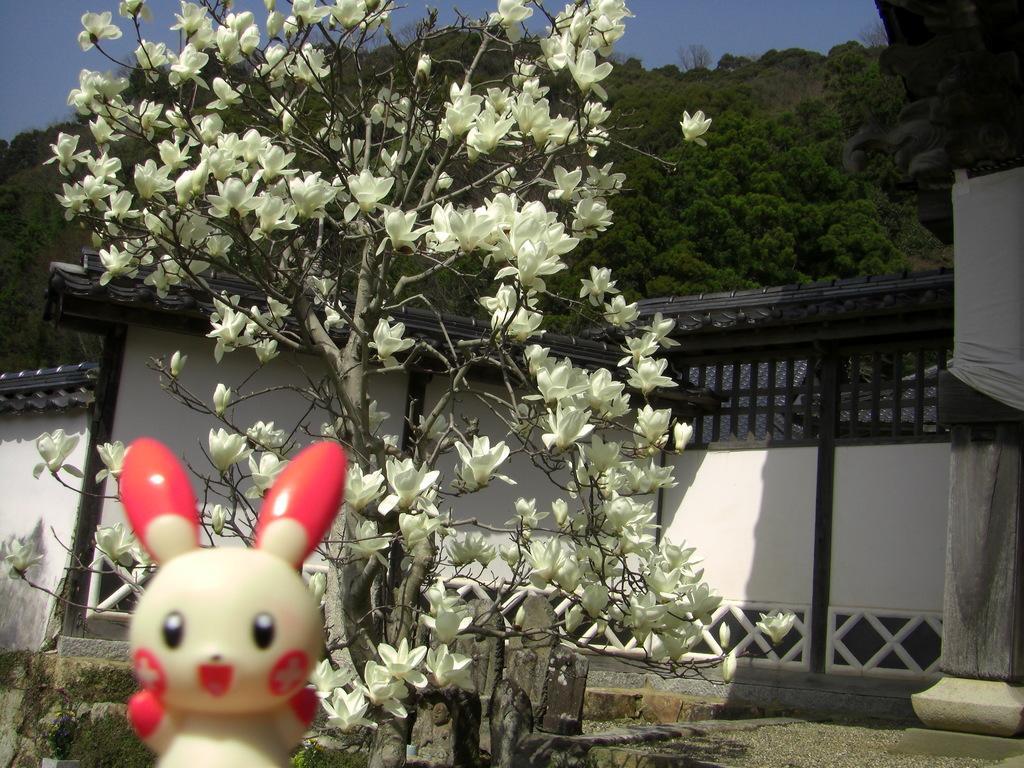Please provide a concise description of this image. At the bottom, we see a toy in red and white color. Behind that, we see a plant which has flowers. These flowers are in white color. Behind that, we see a building in white color with a grey color roof. There are trees in the background. At the top, we see the sky. 